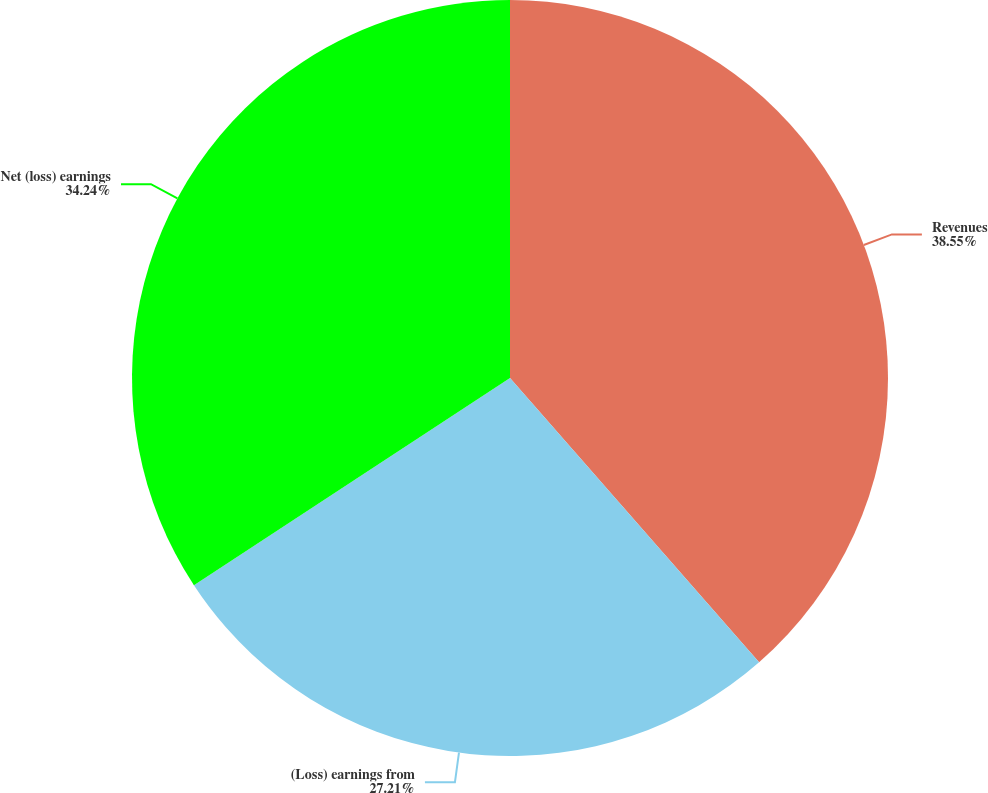<chart> <loc_0><loc_0><loc_500><loc_500><pie_chart><fcel>Revenues<fcel>(Loss) earnings from<fcel>Net (loss) earnings<nl><fcel>38.55%<fcel>27.21%<fcel>34.24%<nl></chart> 